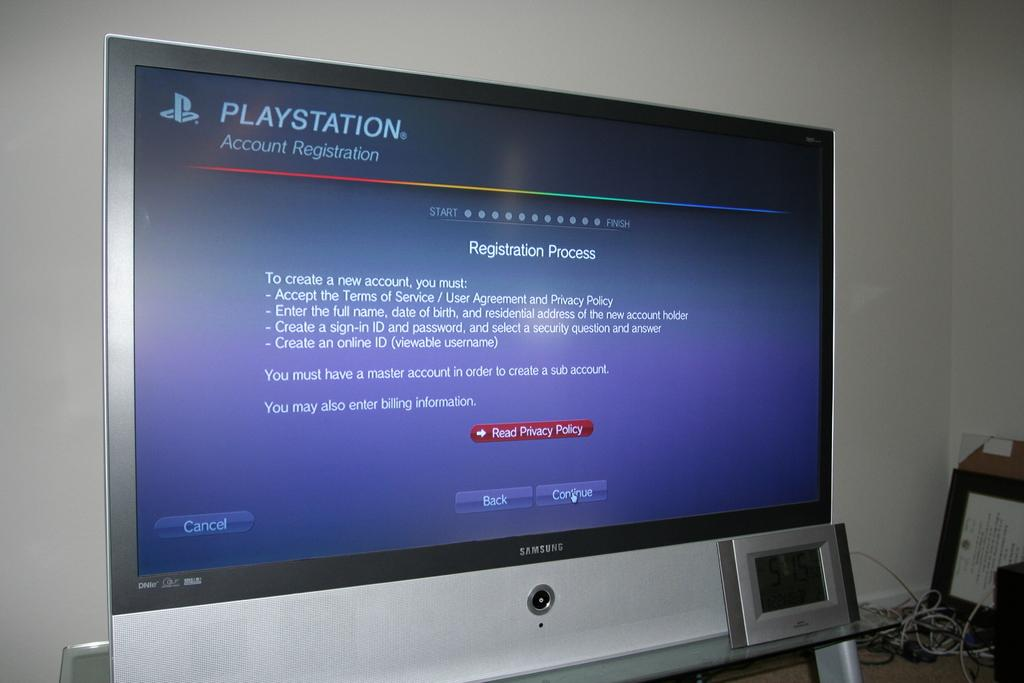<image>
Give a short and clear explanation of the subsequent image. a screen of PLAY STATION for the Registration Process 